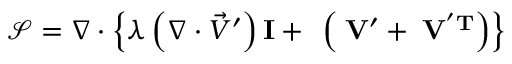<formula> <loc_0><loc_0><loc_500><loc_500>\mathcal { S } = \nabla \cdot \left \{ \lambda \left ( \nabla \cdot \vec { V } ^ { \prime } \right ) I + \mu \left ( \nabla \vec { V } ^ { \prime } + \nabla \vec { V } ^ { ^ { \prime } T } \right ) \right \}</formula> 